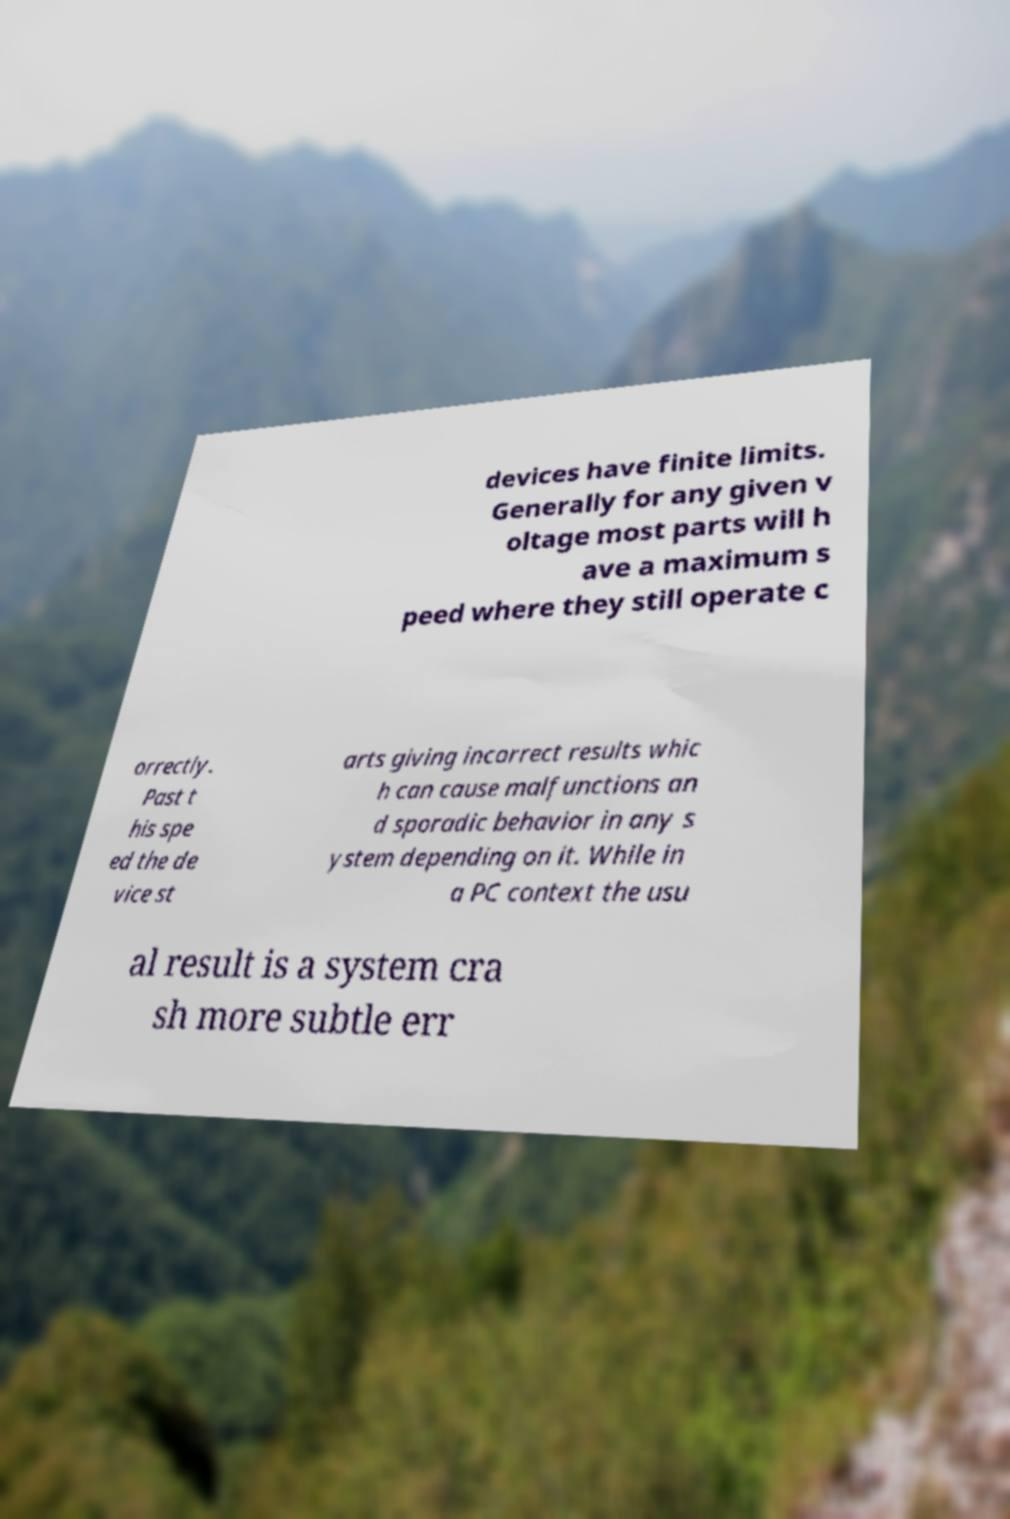Can you accurately transcribe the text from the provided image for me? devices have finite limits. Generally for any given v oltage most parts will h ave a maximum s peed where they still operate c orrectly. Past t his spe ed the de vice st arts giving incorrect results whic h can cause malfunctions an d sporadic behavior in any s ystem depending on it. While in a PC context the usu al result is a system cra sh more subtle err 